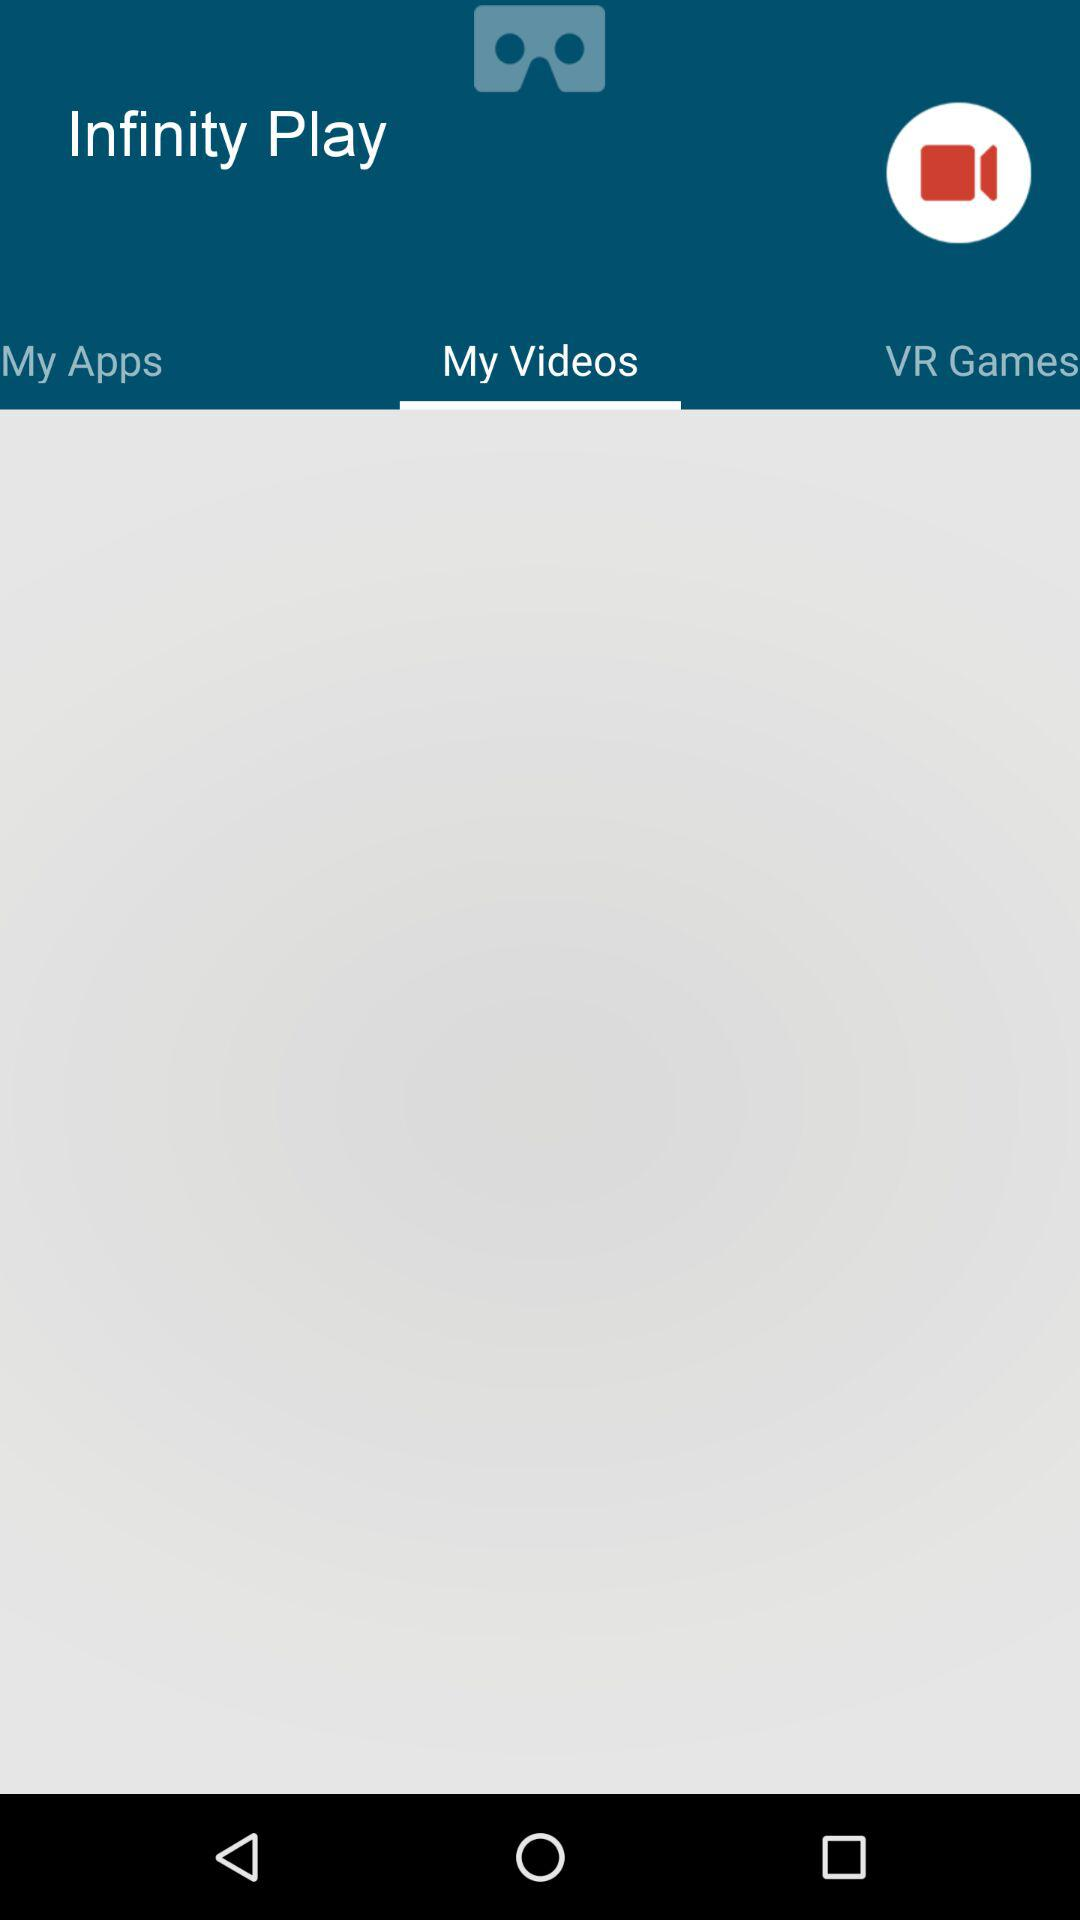What is the name of the application? The name of the application is "Infinity Play". 